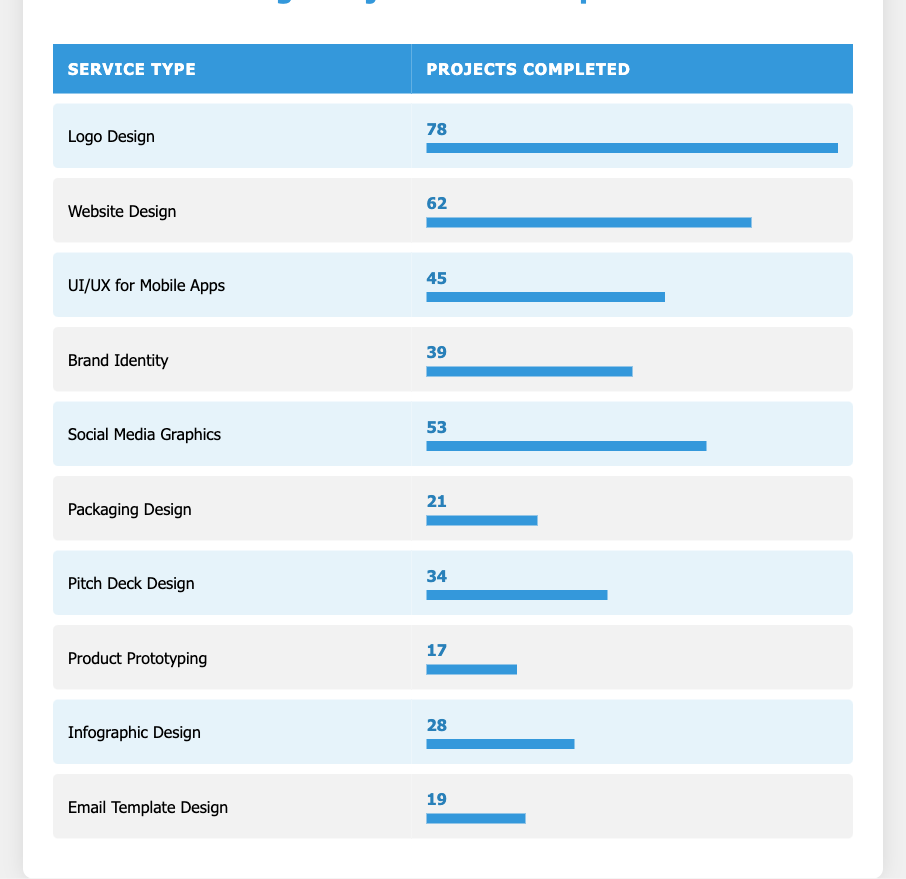What service type had the highest number of projects completed? By looking at the "Projects Completed" column, we can see that "Logo Design" has the highest value at 78.
Answer: Logo Design How many projects were completed for Social Media Graphics? The table shows that the "Projects Completed" for "Social Media Graphics" is 53.
Answer: 53 What is the total number of projects completed for UI/UX for Mobile Apps and Pitch Deck Design? Adding the two values together: UI/UX for Mobile Apps has 45, and Pitch Deck Design has 34. Therefore, 45 + 34 = 79.
Answer: 79 Is it true that more than 60 projects were completed for Website Design? The number of projects for "Website Design" is 62, which is above 60, so the statement is true.
Answer: Yes What is the average number of projects completed across all service types? Adding all completed projects together: 78 + 62 + 45 + 39 + 53 + 21 + 34 + 17 + 28 + 19 =  396. There are 10 service types, so the average is 396 divided by 10, which equals 39.6.
Answer: 39.6 Which service type had fewer projects completed: Packaging Design or Email Template Design? "Packaging Design" completed 21 projects and "Email Template Design" completed 19. Since 19 is less than 21, Email Template Design had fewer projects.
Answer: Email Template Design How many projects were completed for Brand Identity and Infographic Design combined? Combining the numbers: Brand Identity has 39 projects, and Infographic Design has 28, thus 39 + 28 = 67.
Answer: 67 What service type had exactly 34 projects completed? Looking at the table, it is clear that "Pitch Deck Design" has 34 projects completed, making it the only service type with that exact figure.
Answer: Pitch Deck Design 